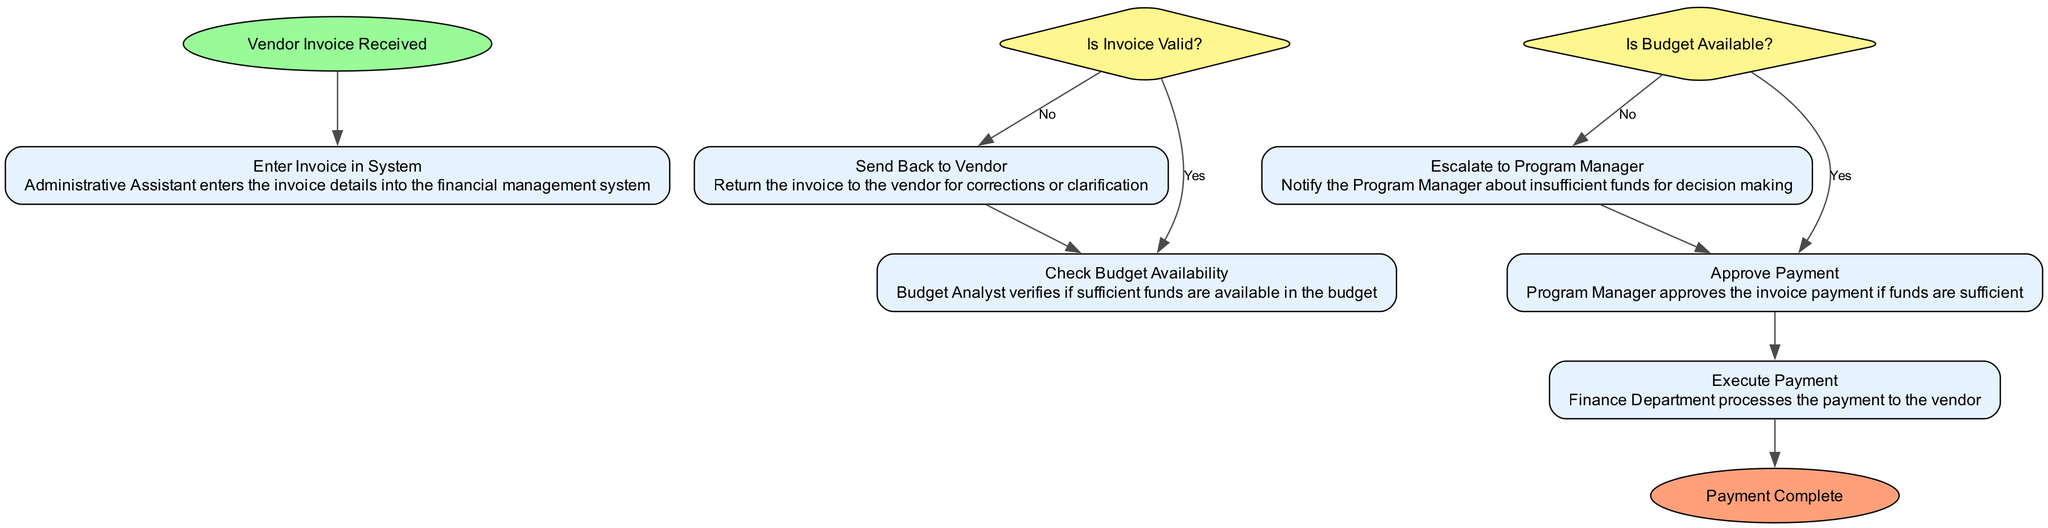What is the first step in the vendor payment workflow? The diagram indicates that the first step is "Vendor Invoice Received," which is clearly labeled at the start of the flowchart.
Answer: Vendor Invoice Received How many decision nodes are present in the diagram? The flowchart contains two decision nodes: "Is Invoice Valid?" and "Is Budget Available?" Each represents a point where a choice is made based on the conditions specified.
Answer: 2 What happens if the invoice is invalid? According to the flowchart, if the invoice is determined to be invalid, the process directs to "Send Back to Vendor," indicating that the invoice must be returned for corrections.
Answer: Send Back to Vendor Which process follows the "Check Budget Availability" step? The subsequent step indicated in the flowchart after "Check Budget Availability" is "Is Budget Available?" This shows that the budget verification comes immediately after checking the availability.
Answer: Is Budget Available? What action is taken if there are insufficient funds? The diagram specifies that if the budget is not available, the process moves to "Escalate to Program Manager," which means notifying the program manager about the financial situation.
Answer: Escalate to Program Manager What is the final step after the payment is executed? The last step of the workflow is labeled as "Payment Complete," indicating that the process concludes after the payment has been successfully processed by the finance department.
Answer: Payment Complete If the invoice is valid and budget is available, what is the next action? The flowchart indicates that if both conditions are met (valid invoice and available budget), the next action taken is "Approve Payment." This signifies the approval from the program manager is needed for payment processing.
Answer: Approve Payment What color represents the start node in the diagram? The start node, "Vendor Invoice Received," is represented in green, specifically filled with a color coded as #98FB98 in the diagram design.
Answer: Green What type of shape is used for decision nodes? The decision nodes in this flowchart are represented as diamonds, which is a conventional shape used to indicate decision points in flowcharts.
Answer: Diamond 